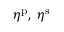Convert formula to latex. <formula><loc_0><loc_0><loc_500><loc_500>\eta ^ { p } , \, \eta ^ { s }</formula> 